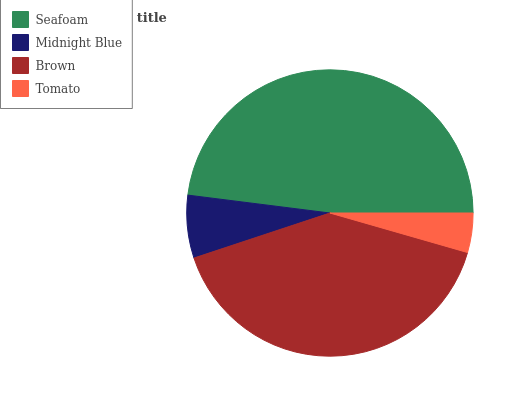Is Tomato the minimum?
Answer yes or no. Yes. Is Seafoam the maximum?
Answer yes or no. Yes. Is Midnight Blue the minimum?
Answer yes or no. No. Is Midnight Blue the maximum?
Answer yes or no. No. Is Seafoam greater than Midnight Blue?
Answer yes or no. Yes. Is Midnight Blue less than Seafoam?
Answer yes or no. Yes. Is Midnight Blue greater than Seafoam?
Answer yes or no. No. Is Seafoam less than Midnight Blue?
Answer yes or no. No. Is Brown the high median?
Answer yes or no. Yes. Is Midnight Blue the low median?
Answer yes or no. Yes. Is Seafoam the high median?
Answer yes or no. No. Is Seafoam the low median?
Answer yes or no. No. 